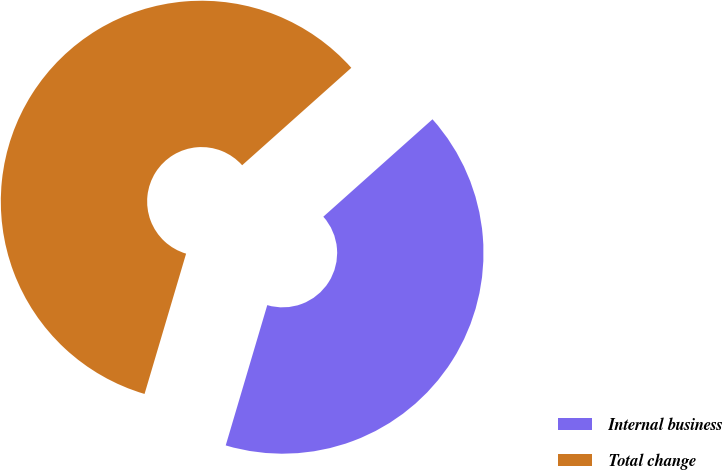Convert chart to OTSL. <chart><loc_0><loc_0><loc_500><loc_500><pie_chart><fcel>Internal business<fcel>Total change<nl><fcel>41.18%<fcel>58.82%<nl></chart> 